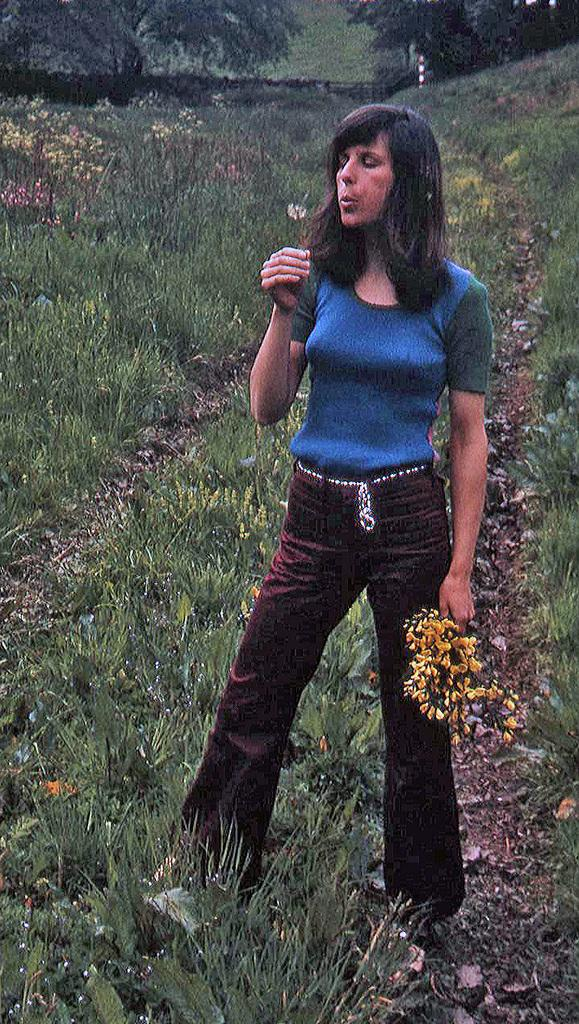Who is the main subject in the image? There is a woman standing in the front of the image. What is the woman holding in the image? The woman is holding flowers. What is the primary feature of the land in the image? The land is covered with grass. What can be seen in the background of the image? There are flowers and trees in the background of the image. What type of cat can be seen starting a race in the image? There is no cat or race present in the image; it features a woman holding flowers and a grassy landscape with flowers and trees in the background. 